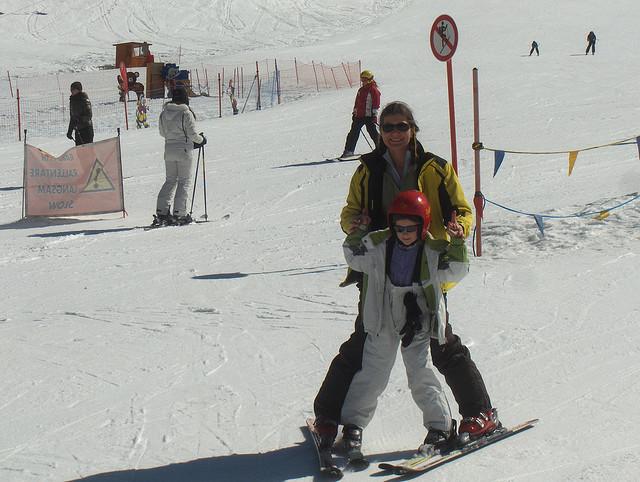How many people are skiing?
Quick response, please. 7. Does this boy know how to ski?
Concise answer only. No. What color is the sign behind the adult and child?
Write a very short answer. Red and white. 